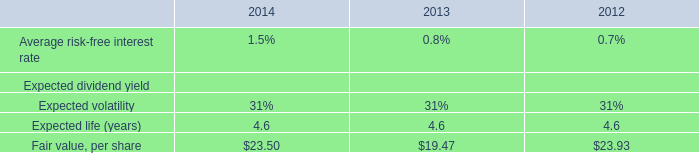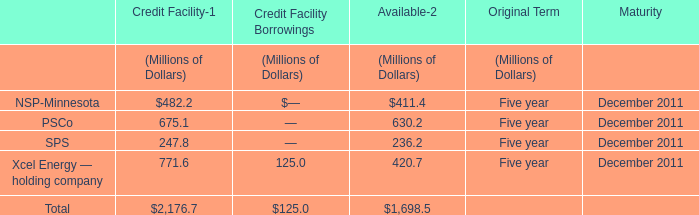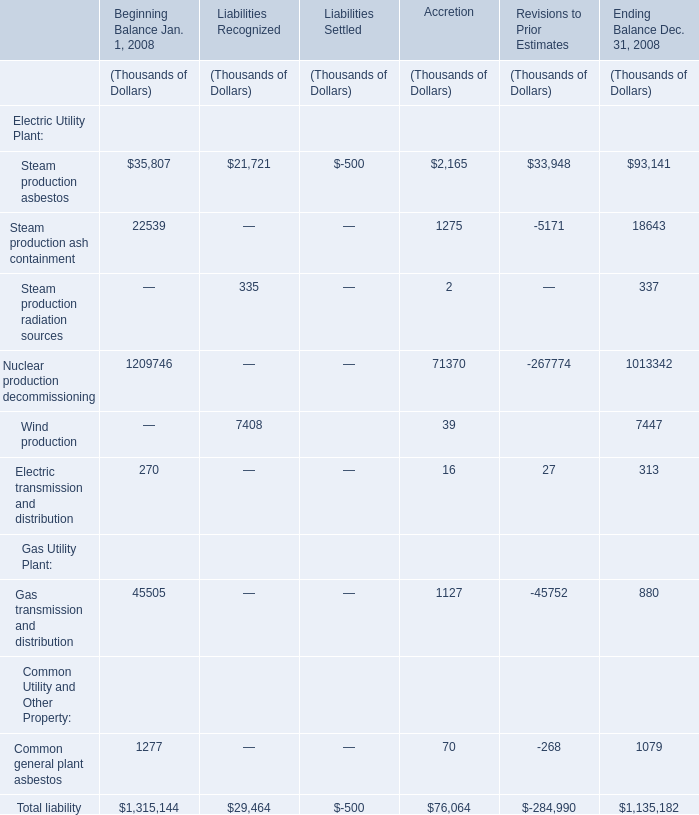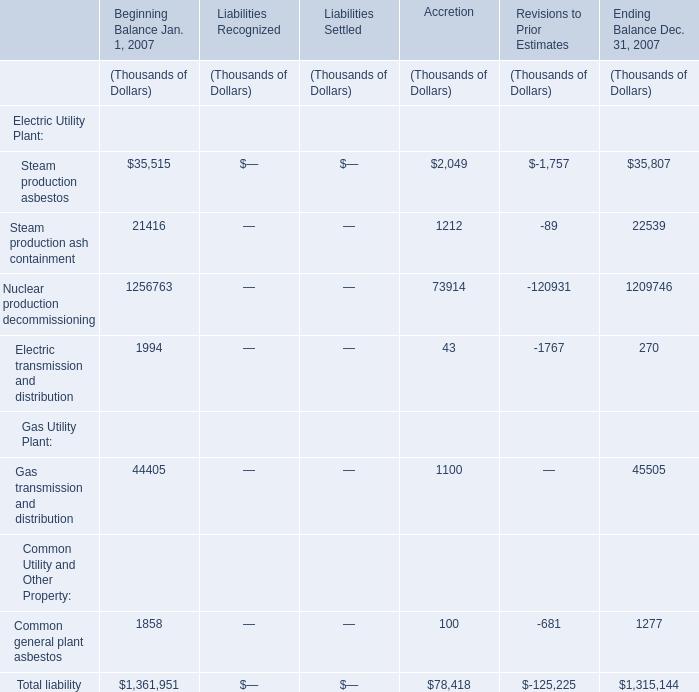What is the percentage of Steam production asbestos of Electric Utility Plant in relation to the total in 2008 for Liabilities Recognized ? 
Computations: (21721 / 29464)
Answer: 0.7372. 